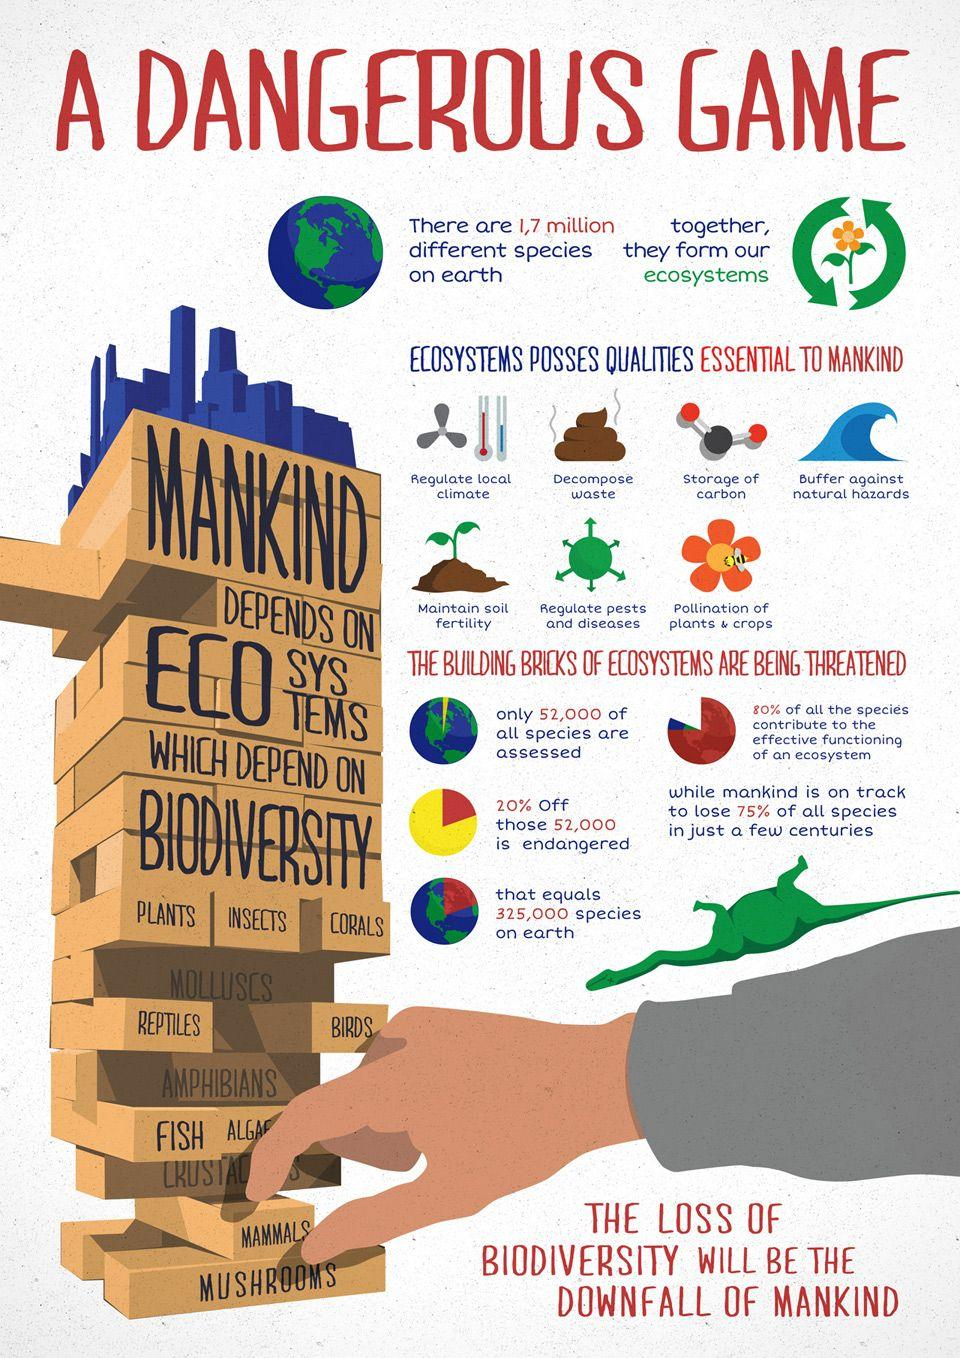Give some essential details in this illustration. The building block to which humans belong is mammals. Based on the assessment of 52,000 species, it is estimated that 10,400 species are endangered. 